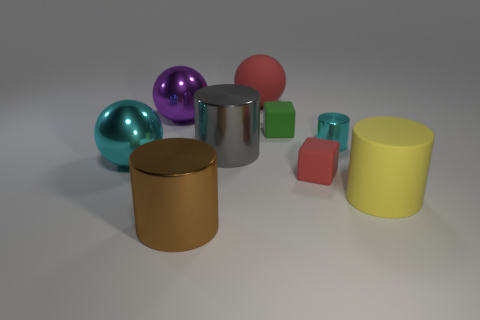Are there any tiny cubes that have the same color as the big matte ball?
Provide a succinct answer. Yes. What number of tiny cyan objects are the same shape as the big brown shiny object?
Make the answer very short. 1. What is the purple object made of?
Make the answer very short. Metal. Is the number of big objects that are to the left of the red ball the same as the number of big brown metallic blocks?
Ensure brevity in your answer.  No. What shape is the yellow rubber thing that is the same size as the cyan ball?
Offer a very short reply. Cylinder. There is a big cyan ball on the left side of the matte cylinder; are there any purple things that are in front of it?
Your response must be concise. No. How many tiny things are either purple metallic balls or red things?
Offer a terse response. 1. Are there any red spheres of the same size as the yellow thing?
Offer a terse response. Yes. What number of metallic things are cylinders or brown cylinders?
Provide a short and direct response. 3. The big metallic object that is the same color as the tiny shiny object is what shape?
Make the answer very short. Sphere. 